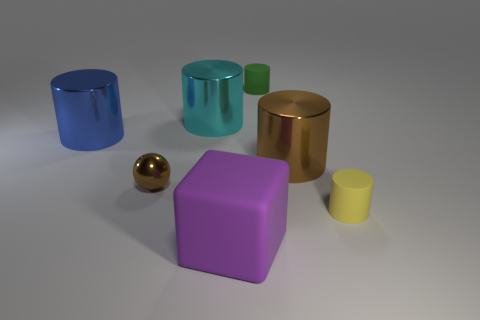How many other objects are the same color as the big matte thing?
Make the answer very short. 0. How many tiny rubber objects are there?
Keep it short and to the point. 2. What number of big objects are both on the right side of the large cyan shiny object and behind the tiny brown object?
Offer a terse response. 1. What material is the sphere?
Provide a short and direct response. Metal. Are there any red metal things?
Your answer should be compact. No. There is a big object on the right side of the small green thing; what color is it?
Your answer should be very brief. Brown. There is a tiny cylinder in front of the small thing that is behind the brown shiny cylinder; how many tiny metal objects are to the right of it?
Provide a succinct answer. 0. There is a large object that is to the left of the small green cylinder and in front of the blue object; what is its material?
Keep it short and to the point. Rubber. Do the tiny ball and the large blue thing that is on the left side of the sphere have the same material?
Offer a very short reply. Yes. Is the number of tiny brown metal things that are in front of the large blue shiny object greater than the number of tiny brown things that are behind the small green matte thing?
Your answer should be compact. Yes. 